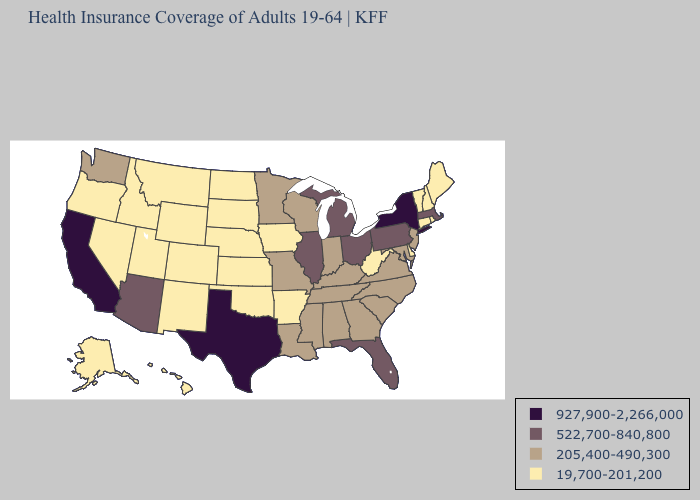What is the highest value in the South ?
Answer briefly. 927,900-2,266,000. Which states hav the highest value in the MidWest?
Concise answer only. Illinois, Michigan, Ohio. Does the first symbol in the legend represent the smallest category?
Give a very brief answer. No. Name the states that have a value in the range 522,700-840,800?
Keep it brief. Arizona, Florida, Illinois, Massachusetts, Michigan, Ohio, Pennsylvania. What is the value of New Jersey?
Keep it brief. 205,400-490,300. Name the states that have a value in the range 927,900-2,266,000?
Quick response, please. California, New York, Texas. What is the value of Georgia?
Concise answer only. 205,400-490,300. Which states have the lowest value in the USA?
Quick response, please. Alaska, Arkansas, Colorado, Connecticut, Delaware, Hawaii, Idaho, Iowa, Kansas, Maine, Montana, Nebraska, Nevada, New Hampshire, New Mexico, North Dakota, Oklahoma, Oregon, Rhode Island, South Dakota, Utah, Vermont, West Virginia, Wyoming. Among the states that border Florida , which have the lowest value?
Keep it brief. Alabama, Georgia. What is the value of Arizona?
Concise answer only. 522,700-840,800. Does Utah have the lowest value in the USA?
Give a very brief answer. Yes. Is the legend a continuous bar?
Keep it brief. No. Name the states that have a value in the range 205,400-490,300?
Short answer required. Alabama, Georgia, Indiana, Kentucky, Louisiana, Maryland, Minnesota, Mississippi, Missouri, New Jersey, North Carolina, South Carolina, Tennessee, Virginia, Washington, Wisconsin. What is the value of Iowa?
Concise answer only. 19,700-201,200. Is the legend a continuous bar?
Answer briefly. No. 